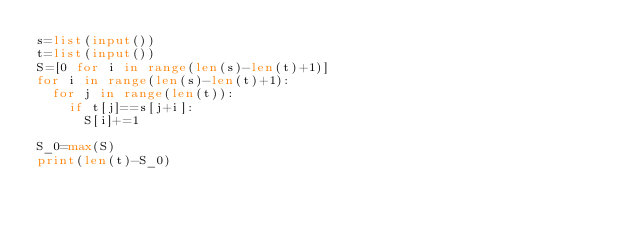Convert code to text. <code><loc_0><loc_0><loc_500><loc_500><_Python_>s=list(input())
t=list(input())
S=[0 for i in range(len(s)-len(t)+1)]
for i in range(len(s)-len(t)+1):
  for j in range(len(t)):
    if t[j]==s[j+i]:
      S[i]+=1
      
S_0=max(S)
print(len(t)-S_0)</code> 